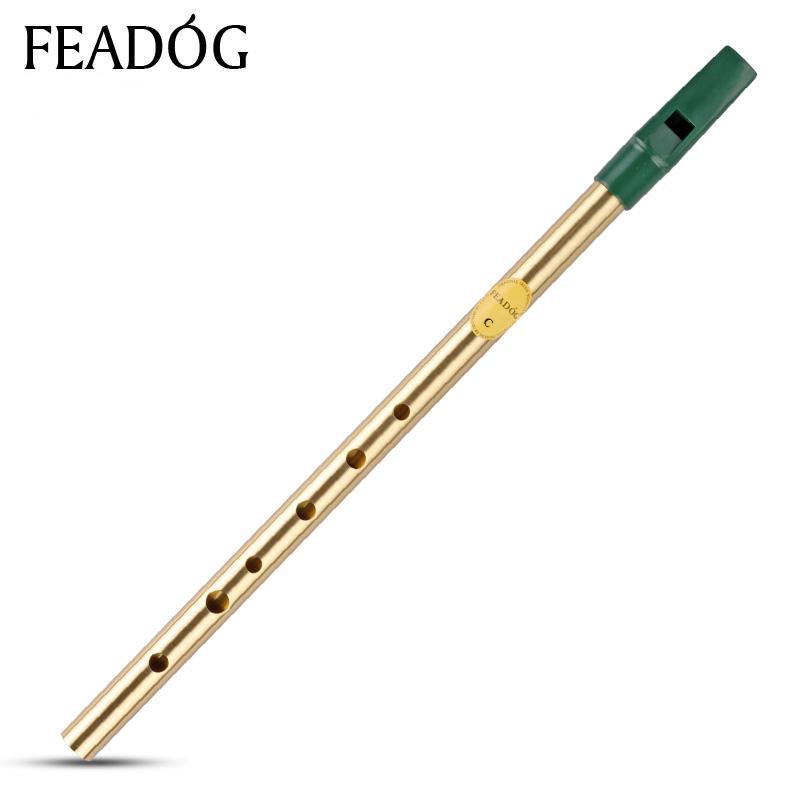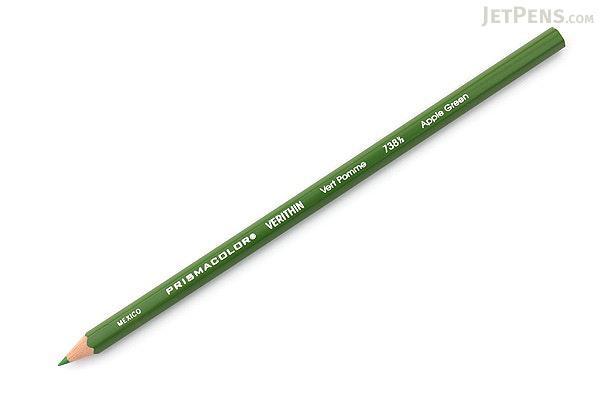The first image is the image on the left, the second image is the image on the right. For the images shown, is this caption "There are two flutes." true? Answer yes or no. No. The first image is the image on the left, the second image is the image on the right. Examine the images to the left and right. Is the description "One writing implement is visible." accurate? Answer yes or no. Yes. 